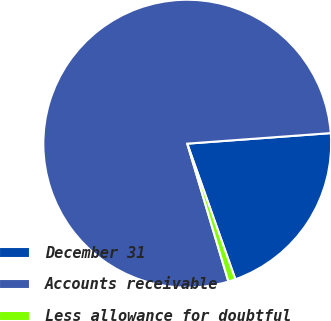Convert chart to OTSL. <chart><loc_0><loc_0><loc_500><loc_500><pie_chart><fcel>December 31<fcel>Accounts receivable<fcel>Less allowance for doubtful<nl><fcel>20.74%<fcel>78.45%<fcel>0.81%<nl></chart> 